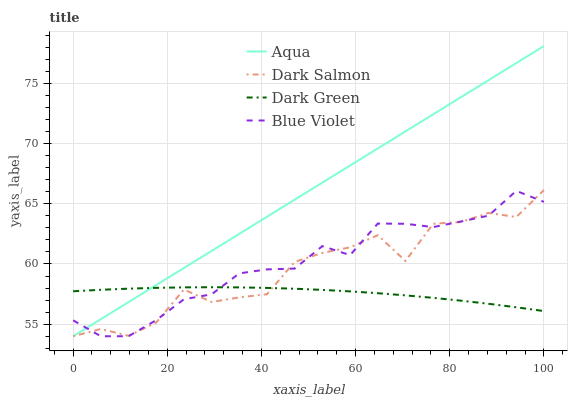Does Dark Green have the minimum area under the curve?
Answer yes or no. Yes. Does Aqua have the maximum area under the curve?
Answer yes or no. Yes. Does Dark Salmon have the minimum area under the curve?
Answer yes or no. No. Does Dark Salmon have the maximum area under the curve?
Answer yes or no. No. Is Aqua the smoothest?
Answer yes or no. Yes. Is Dark Salmon the roughest?
Answer yes or no. Yes. Is Blue Violet the smoothest?
Answer yes or no. No. Is Blue Violet the roughest?
Answer yes or no. No. Does Dark Green have the lowest value?
Answer yes or no. No. Does Aqua have the highest value?
Answer yes or no. Yes. Does Dark Salmon have the highest value?
Answer yes or no. No. 